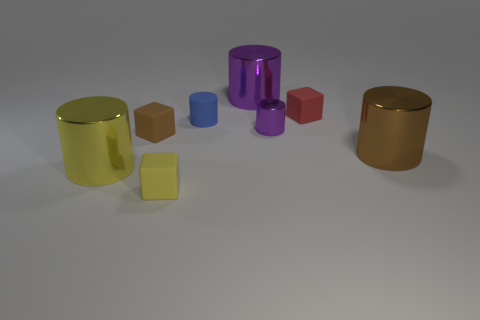Add 1 metallic cylinders. How many objects exist? 9 Subtract all cylinders. How many objects are left? 3 Add 1 yellow rubber cubes. How many yellow rubber cubes are left? 2 Add 2 large purple metallic objects. How many large purple metallic objects exist? 3 Subtract 0 green balls. How many objects are left? 8 Subtract all large yellow shiny things. Subtract all small blue objects. How many objects are left? 6 